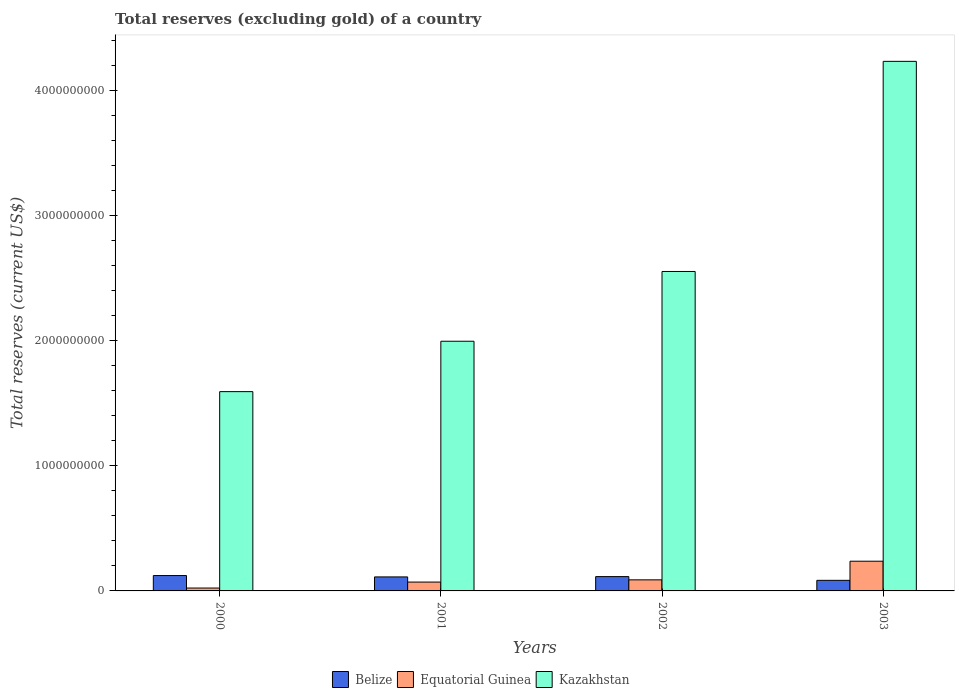How many different coloured bars are there?
Ensure brevity in your answer.  3. How many bars are there on the 2nd tick from the left?
Make the answer very short. 3. How many bars are there on the 1st tick from the right?
Your answer should be very brief. 3. In how many cases, is the number of bars for a given year not equal to the number of legend labels?
Keep it short and to the point. 0. What is the total reserves (excluding gold) in Belize in 2003?
Your answer should be very brief. 8.47e+07. Across all years, what is the maximum total reserves (excluding gold) in Equatorial Guinea?
Give a very brief answer. 2.38e+08. Across all years, what is the minimum total reserves (excluding gold) in Belize?
Provide a short and direct response. 8.47e+07. In which year was the total reserves (excluding gold) in Kazakhstan maximum?
Offer a very short reply. 2003. What is the total total reserves (excluding gold) in Kazakhstan in the graph?
Offer a terse response. 1.04e+1. What is the difference between the total reserves (excluding gold) in Kazakhstan in 2001 and that in 2003?
Your answer should be compact. -2.24e+09. What is the difference between the total reserves (excluding gold) in Belize in 2000 and the total reserves (excluding gold) in Equatorial Guinea in 2001?
Ensure brevity in your answer.  5.20e+07. What is the average total reserves (excluding gold) in Belize per year?
Provide a short and direct response. 1.09e+08. In the year 2003, what is the difference between the total reserves (excluding gold) in Kazakhstan and total reserves (excluding gold) in Belize?
Ensure brevity in your answer.  4.15e+09. In how many years, is the total reserves (excluding gold) in Equatorial Guinea greater than 200000000 US$?
Give a very brief answer. 1. What is the ratio of the total reserves (excluding gold) in Kazakhstan in 2000 to that in 2001?
Make the answer very short. 0.8. What is the difference between the highest and the second highest total reserves (excluding gold) in Kazakhstan?
Your response must be concise. 1.68e+09. What is the difference between the highest and the lowest total reserves (excluding gold) in Kazakhstan?
Your answer should be very brief. 2.64e+09. What does the 3rd bar from the left in 2001 represents?
Your answer should be very brief. Kazakhstan. What does the 3rd bar from the right in 2001 represents?
Offer a very short reply. Belize. Does the graph contain any zero values?
Provide a succinct answer. No. How are the legend labels stacked?
Offer a very short reply. Horizontal. What is the title of the graph?
Ensure brevity in your answer.  Total reserves (excluding gold) of a country. What is the label or title of the Y-axis?
Give a very brief answer. Total reserves (current US$). What is the Total reserves (current US$) of Belize in 2000?
Offer a terse response. 1.23e+08. What is the Total reserves (current US$) in Equatorial Guinea in 2000?
Give a very brief answer. 2.30e+07. What is the Total reserves (current US$) in Kazakhstan in 2000?
Provide a succinct answer. 1.59e+09. What is the Total reserves (current US$) in Belize in 2001?
Make the answer very short. 1.12e+08. What is the Total reserves (current US$) in Equatorial Guinea in 2001?
Ensure brevity in your answer.  7.09e+07. What is the Total reserves (current US$) in Kazakhstan in 2001?
Your answer should be very brief. 2.00e+09. What is the Total reserves (current US$) of Belize in 2002?
Give a very brief answer. 1.15e+08. What is the Total reserves (current US$) in Equatorial Guinea in 2002?
Provide a succinct answer. 8.85e+07. What is the Total reserves (current US$) of Kazakhstan in 2002?
Give a very brief answer. 2.56e+09. What is the Total reserves (current US$) of Belize in 2003?
Give a very brief answer. 8.47e+07. What is the Total reserves (current US$) in Equatorial Guinea in 2003?
Make the answer very short. 2.38e+08. What is the Total reserves (current US$) in Kazakhstan in 2003?
Ensure brevity in your answer.  4.24e+09. Across all years, what is the maximum Total reserves (current US$) of Belize?
Give a very brief answer. 1.23e+08. Across all years, what is the maximum Total reserves (current US$) in Equatorial Guinea?
Offer a very short reply. 2.38e+08. Across all years, what is the maximum Total reserves (current US$) in Kazakhstan?
Offer a terse response. 4.24e+09. Across all years, what is the minimum Total reserves (current US$) of Belize?
Your response must be concise. 8.47e+07. Across all years, what is the minimum Total reserves (current US$) in Equatorial Guinea?
Offer a very short reply. 2.30e+07. Across all years, what is the minimum Total reserves (current US$) of Kazakhstan?
Your response must be concise. 1.59e+09. What is the total Total reserves (current US$) of Belize in the graph?
Your answer should be very brief. 4.34e+08. What is the total Total reserves (current US$) in Equatorial Guinea in the graph?
Keep it short and to the point. 4.20e+08. What is the total Total reserves (current US$) of Kazakhstan in the graph?
Ensure brevity in your answer.  1.04e+1. What is the difference between the Total reserves (current US$) of Belize in 2000 and that in 2001?
Offer a terse response. 1.09e+07. What is the difference between the Total reserves (current US$) in Equatorial Guinea in 2000 and that in 2001?
Give a very brief answer. -4.78e+07. What is the difference between the Total reserves (current US$) of Kazakhstan in 2000 and that in 2001?
Offer a very short reply. -4.03e+08. What is the difference between the Total reserves (current US$) in Belize in 2000 and that in 2002?
Ensure brevity in your answer.  8.39e+06. What is the difference between the Total reserves (current US$) in Equatorial Guinea in 2000 and that in 2002?
Your answer should be very brief. -6.55e+07. What is the difference between the Total reserves (current US$) of Kazakhstan in 2000 and that in 2002?
Give a very brief answer. -9.61e+08. What is the difference between the Total reserves (current US$) of Belize in 2000 and that in 2003?
Your response must be concise. 3.82e+07. What is the difference between the Total reserves (current US$) of Equatorial Guinea in 2000 and that in 2003?
Offer a very short reply. -2.15e+08. What is the difference between the Total reserves (current US$) of Kazakhstan in 2000 and that in 2003?
Ensure brevity in your answer.  -2.64e+09. What is the difference between the Total reserves (current US$) of Belize in 2001 and that in 2002?
Ensure brevity in your answer.  -2.46e+06. What is the difference between the Total reserves (current US$) in Equatorial Guinea in 2001 and that in 2002?
Keep it short and to the point. -1.77e+07. What is the difference between the Total reserves (current US$) of Kazakhstan in 2001 and that in 2002?
Provide a succinct answer. -5.58e+08. What is the difference between the Total reserves (current US$) in Belize in 2001 and that in 2003?
Keep it short and to the point. 2.74e+07. What is the difference between the Total reserves (current US$) of Equatorial Guinea in 2001 and that in 2003?
Provide a succinct answer. -1.67e+08. What is the difference between the Total reserves (current US$) in Kazakhstan in 2001 and that in 2003?
Your answer should be very brief. -2.24e+09. What is the difference between the Total reserves (current US$) in Belize in 2002 and that in 2003?
Keep it short and to the point. 2.98e+07. What is the difference between the Total reserves (current US$) of Equatorial Guinea in 2002 and that in 2003?
Your answer should be very brief. -1.49e+08. What is the difference between the Total reserves (current US$) in Kazakhstan in 2002 and that in 2003?
Your answer should be very brief. -1.68e+09. What is the difference between the Total reserves (current US$) of Belize in 2000 and the Total reserves (current US$) of Equatorial Guinea in 2001?
Keep it short and to the point. 5.20e+07. What is the difference between the Total reserves (current US$) of Belize in 2000 and the Total reserves (current US$) of Kazakhstan in 2001?
Provide a short and direct response. -1.87e+09. What is the difference between the Total reserves (current US$) of Equatorial Guinea in 2000 and the Total reserves (current US$) of Kazakhstan in 2001?
Your answer should be very brief. -1.97e+09. What is the difference between the Total reserves (current US$) of Belize in 2000 and the Total reserves (current US$) of Equatorial Guinea in 2002?
Ensure brevity in your answer.  3.44e+07. What is the difference between the Total reserves (current US$) in Belize in 2000 and the Total reserves (current US$) in Kazakhstan in 2002?
Offer a terse response. -2.43e+09. What is the difference between the Total reserves (current US$) in Equatorial Guinea in 2000 and the Total reserves (current US$) in Kazakhstan in 2002?
Your answer should be compact. -2.53e+09. What is the difference between the Total reserves (current US$) of Belize in 2000 and the Total reserves (current US$) of Equatorial Guinea in 2003?
Your answer should be compact. -1.15e+08. What is the difference between the Total reserves (current US$) of Belize in 2000 and the Total reserves (current US$) of Kazakhstan in 2003?
Offer a terse response. -4.11e+09. What is the difference between the Total reserves (current US$) in Equatorial Guinea in 2000 and the Total reserves (current US$) in Kazakhstan in 2003?
Make the answer very short. -4.21e+09. What is the difference between the Total reserves (current US$) of Belize in 2001 and the Total reserves (current US$) of Equatorial Guinea in 2002?
Offer a very short reply. 2.35e+07. What is the difference between the Total reserves (current US$) in Belize in 2001 and the Total reserves (current US$) in Kazakhstan in 2002?
Your answer should be very brief. -2.44e+09. What is the difference between the Total reserves (current US$) in Equatorial Guinea in 2001 and the Total reserves (current US$) in Kazakhstan in 2002?
Your response must be concise. -2.48e+09. What is the difference between the Total reserves (current US$) in Belize in 2001 and the Total reserves (current US$) in Equatorial Guinea in 2003?
Provide a succinct answer. -1.26e+08. What is the difference between the Total reserves (current US$) in Belize in 2001 and the Total reserves (current US$) in Kazakhstan in 2003?
Make the answer very short. -4.12e+09. What is the difference between the Total reserves (current US$) of Equatorial Guinea in 2001 and the Total reserves (current US$) of Kazakhstan in 2003?
Your response must be concise. -4.17e+09. What is the difference between the Total reserves (current US$) of Belize in 2002 and the Total reserves (current US$) of Equatorial Guinea in 2003?
Provide a short and direct response. -1.23e+08. What is the difference between the Total reserves (current US$) in Belize in 2002 and the Total reserves (current US$) in Kazakhstan in 2003?
Offer a terse response. -4.12e+09. What is the difference between the Total reserves (current US$) in Equatorial Guinea in 2002 and the Total reserves (current US$) in Kazakhstan in 2003?
Your response must be concise. -4.15e+09. What is the average Total reserves (current US$) of Belize per year?
Your answer should be very brief. 1.09e+08. What is the average Total reserves (current US$) in Equatorial Guinea per year?
Ensure brevity in your answer.  1.05e+08. What is the average Total reserves (current US$) of Kazakhstan per year?
Your response must be concise. 2.60e+09. In the year 2000, what is the difference between the Total reserves (current US$) in Belize and Total reserves (current US$) in Equatorial Guinea?
Give a very brief answer. 9.99e+07. In the year 2000, what is the difference between the Total reserves (current US$) of Belize and Total reserves (current US$) of Kazakhstan?
Provide a short and direct response. -1.47e+09. In the year 2000, what is the difference between the Total reserves (current US$) of Equatorial Guinea and Total reserves (current US$) of Kazakhstan?
Keep it short and to the point. -1.57e+09. In the year 2001, what is the difference between the Total reserves (current US$) in Belize and Total reserves (current US$) in Equatorial Guinea?
Provide a succinct answer. 4.12e+07. In the year 2001, what is the difference between the Total reserves (current US$) in Belize and Total reserves (current US$) in Kazakhstan?
Offer a terse response. -1.89e+09. In the year 2001, what is the difference between the Total reserves (current US$) of Equatorial Guinea and Total reserves (current US$) of Kazakhstan?
Provide a short and direct response. -1.93e+09. In the year 2002, what is the difference between the Total reserves (current US$) of Belize and Total reserves (current US$) of Equatorial Guinea?
Your response must be concise. 2.60e+07. In the year 2002, what is the difference between the Total reserves (current US$) in Belize and Total reserves (current US$) in Kazakhstan?
Provide a short and direct response. -2.44e+09. In the year 2002, what is the difference between the Total reserves (current US$) in Equatorial Guinea and Total reserves (current US$) in Kazakhstan?
Offer a terse response. -2.47e+09. In the year 2003, what is the difference between the Total reserves (current US$) of Belize and Total reserves (current US$) of Equatorial Guinea?
Keep it short and to the point. -1.53e+08. In the year 2003, what is the difference between the Total reserves (current US$) of Belize and Total reserves (current US$) of Kazakhstan?
Provide a succinct answer. -4.15e+09. In the year 2003, what is the difference between the Total reserves (current US$) of Equatorial Guinea and Total reserves (current US$) of Kazakhstan?
Make the answer very short. -4.00e+09. What is the ratio of the Total reserves (current US$) of Belize in 2000 to that in 2001?
Provide a short and direct response. 1.1. What is the ratio of the Total reserves (current US$) of Equatorial Guinea in 2000 to that in 2001?
Your answer should be very brief. 0.32. What is the ratio of the Total reserves (current US$) in Kazakhstan in 2000 to that in 2001?
Your answer should be compact. 0.8. What is the ratio of the Total reserves (current US$) of Belize in 2000 to that in 2002?
Keep it short and to the point. 1.07. What is the ratio of the Total reserves (current US$) of Equatorial Guinea in 2000 to that in 2002?
Provide a succinct answer. 0.26. What is the ratio of the Total reserves (current US$) in Kazakhstan in 2000 to that in 2002?
Offer a very short reply. 0.62. What is the ratio of the Total reserves (current US$) in Belize in 2000 to that in 2003?
Offer a very short reply. 1.45. What is the ratio of the Total reserves (current US$) of Equatorial Guinea in 2000 to that in 2003?
Offer a very short reply. 0.1. What is the ratio of the Total reserves (current US$) in Kazakhstan in 2000 to that in 2003?
Keep it short and to the point. 0.38. What is the ratio of the Total reserves (current US$) in Belize in 2001 to that in 2002?
Provide a succinct answer. 0.98. What is the ratio of the Total reserves (current US$) of Equatorial Guinea in 2001 to that in 2002?
Provide a short and direct response. 0.8. What is the ratio of the Total reserves (current US$) of Kazakhstan in 2001 to that in 2002?
Ensure brevity in your answer.  0.78. What is the ratio of the Total reserves (current US$) in Belize in 2001 to that in 2003?
Your answer should be compact. 1.32. What is the ratio of the Total reserves (current US$) of Equatorial Guinea in 2001 to that in 2003?
Your response must be concise. 0.3. What is the ratio of the Total reserves (current US$) in Kazakhstan in 2001 to that in 2003?
Ensure brevity in your answer.  0.47. What is the ratio of the Total reserves (current US$) of Belize in 2002 to that in 2003?
Offer a terse response. 1.35. What is the ratio of the Total reserves (current US$) in Equatorial Guinea in 2002 to that in 2003?
Provide a succinct answer. 0.37. What is the ratio of the Total reserves (current US$) in Kazakhstan in 2002 to that in 2003?
Give a very brief answer. 0.6. What is the difference between the highest and the second highest Total reserves (current US$) of Belize?
Your answer should be compact. 8.39e+06. What is the difference between the highest and the second highest Total reserves (current US$) in Equatorial Guinea?
Provide a short and direct response. 1.49e+08. What is the difference between the highest and the second highest Total reserves (current US$) of Kazakhstan?
Provide a short and direct response. 1.68e+09. What is the difference between the highest and the lowest Total reserves (current US$) of Belize?
Give a very brief answer. 3.82e+07. What is the difference between the highest and the lowest Total reserves (current US$) of Equatorial Guinea?
Give a very brief answer. 2.15e+08. What is the difference between the highest and the lowest Total reserves (current US$) in Kazakhstan?
Your response must be concise. 2.64e+09. 